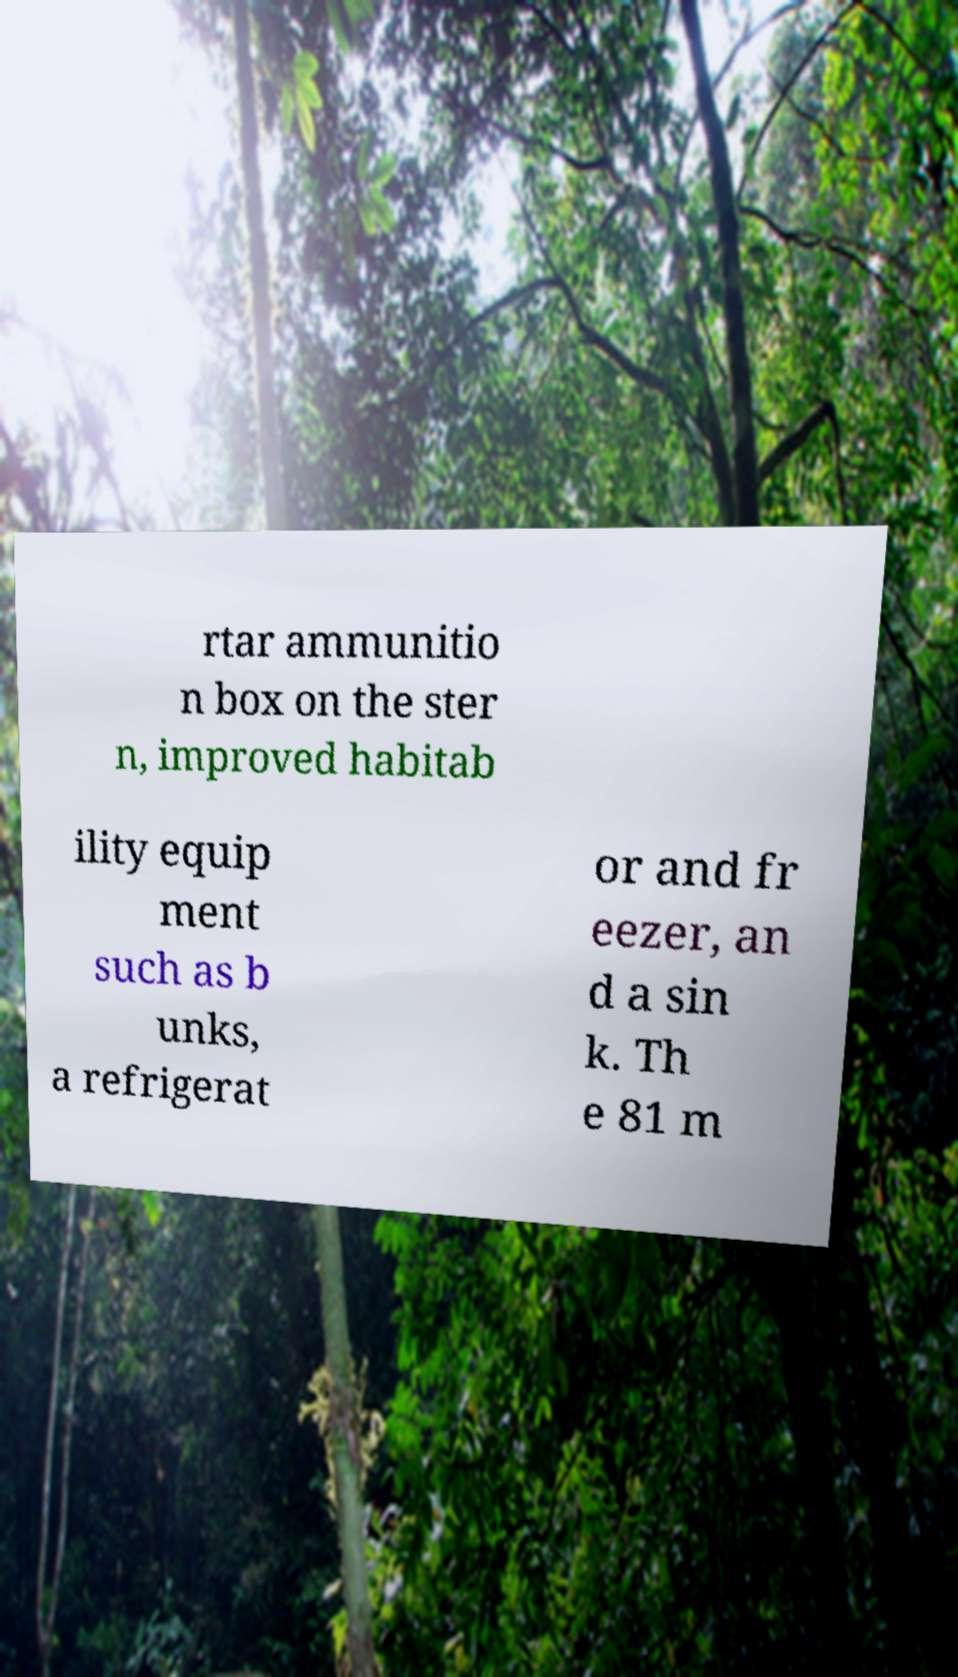Please identify and transcribe the text found in this image. rtar ammunitio n box on the ster n, improved habitab ility equip ment such as b unks, a refrigerat or and fr eezer, an d a sin k. Th e 81 m 